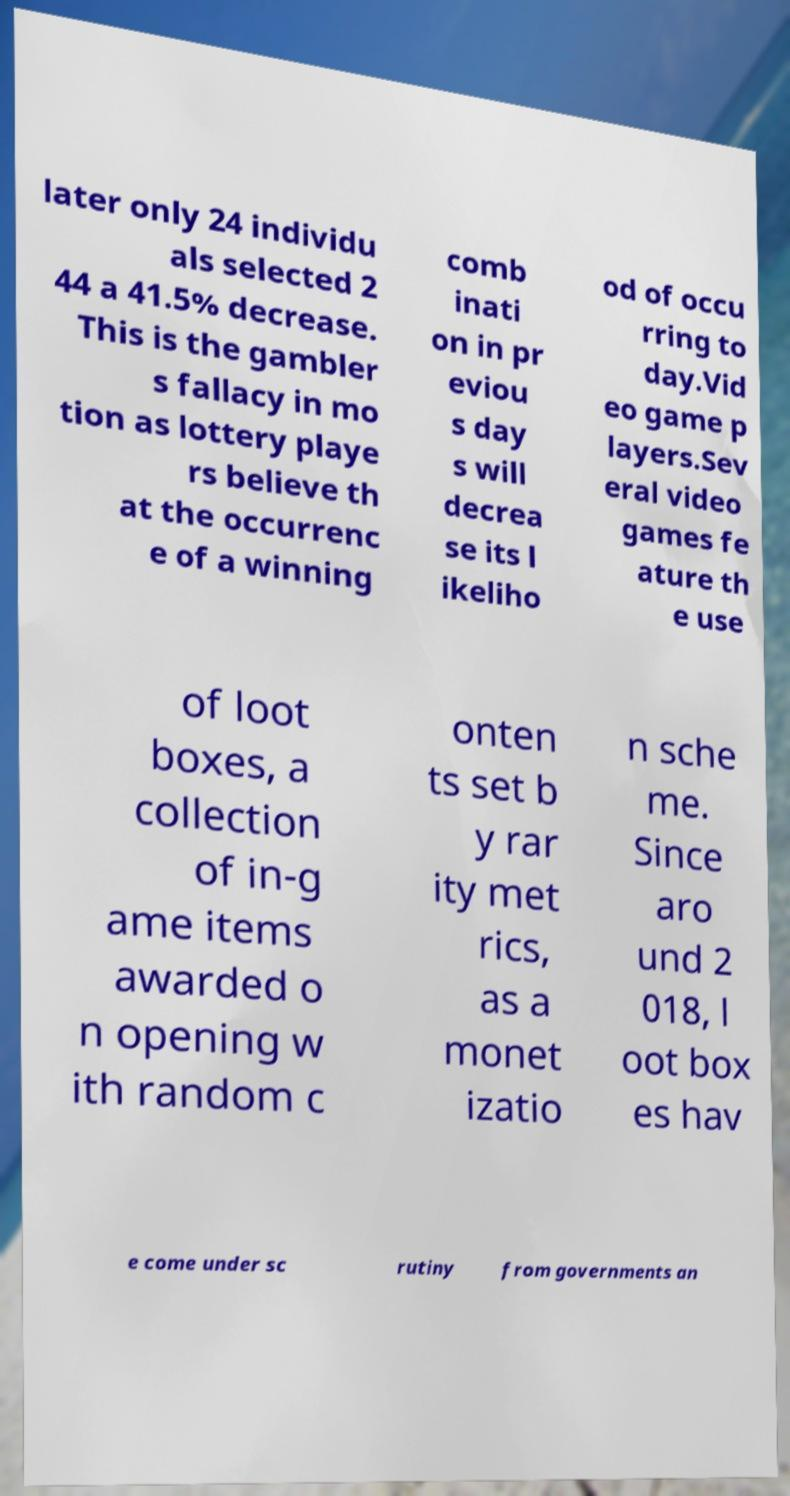Please identify and transcribe the text found in this image. later only 24 individu als selected 2 44 a 41.5% decrease. This is the gambler s fallacy in mo tion as lottery playe rs believe th at the occurrenc e of a winning comb inati on in pr eviou s day s will decrea se its l ikeliho od of occu rring to day.Vid eo game p layers.Sev eral video games fe ature th e use of loot boxes, a collection of in-g ame items awarded o n opening w ith random c onten ts set b y rar ity met rics, as a monet izatio n sche me. Since aro und 2 018, l oot box es hav e come under sc rutiny from governments an 